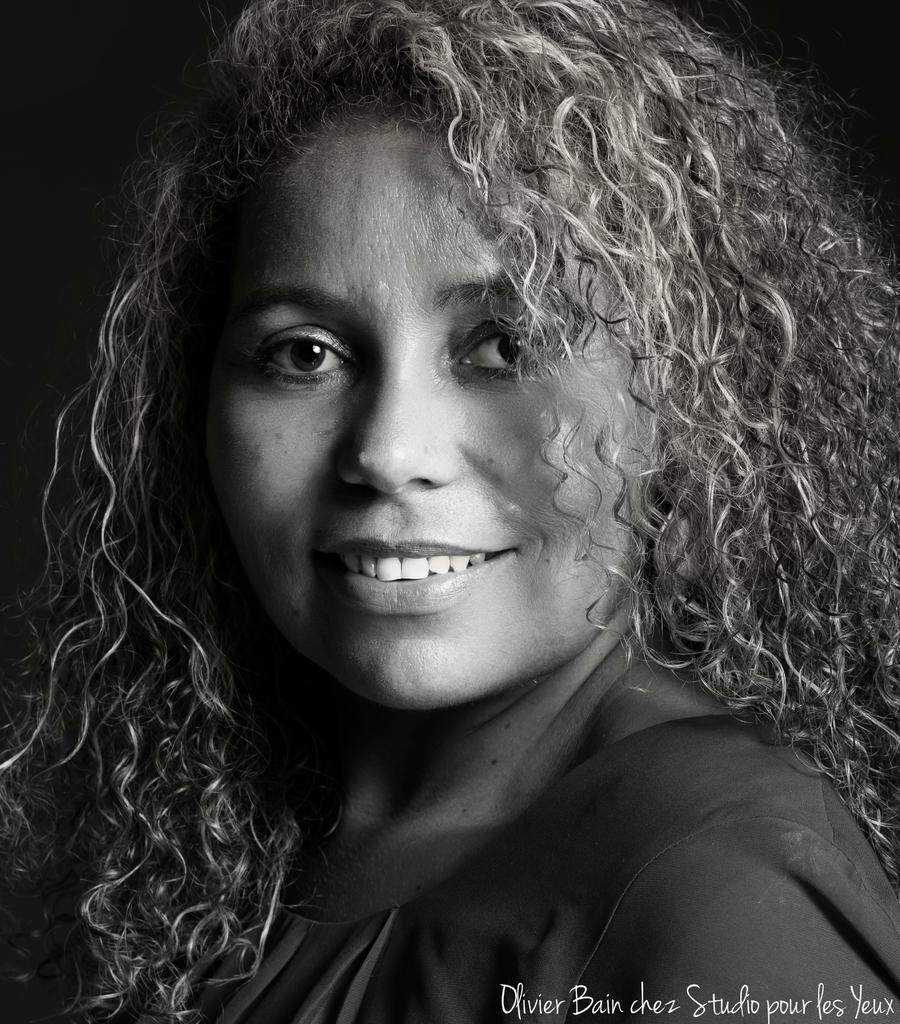Can you describe this image briefly? In the image in the center, we can see one woman smiling, which we can see on her face. In the bottom right side of the image, we can see something written. 